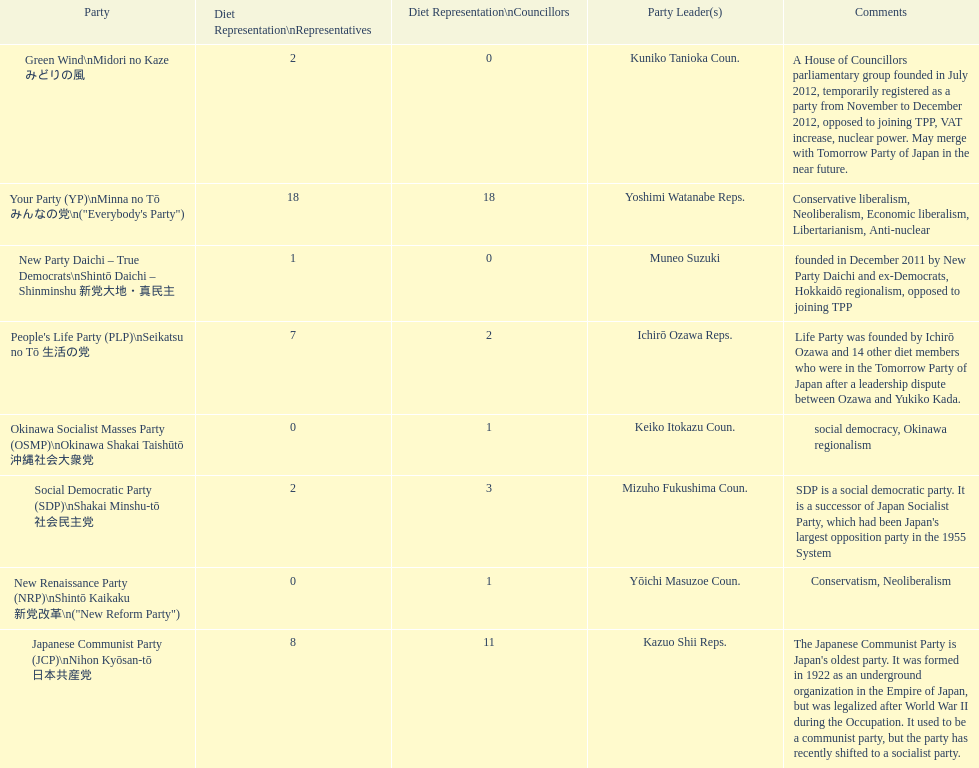What party is listed previous to the new renaissance party? New Party Daichi - True Democrats. 